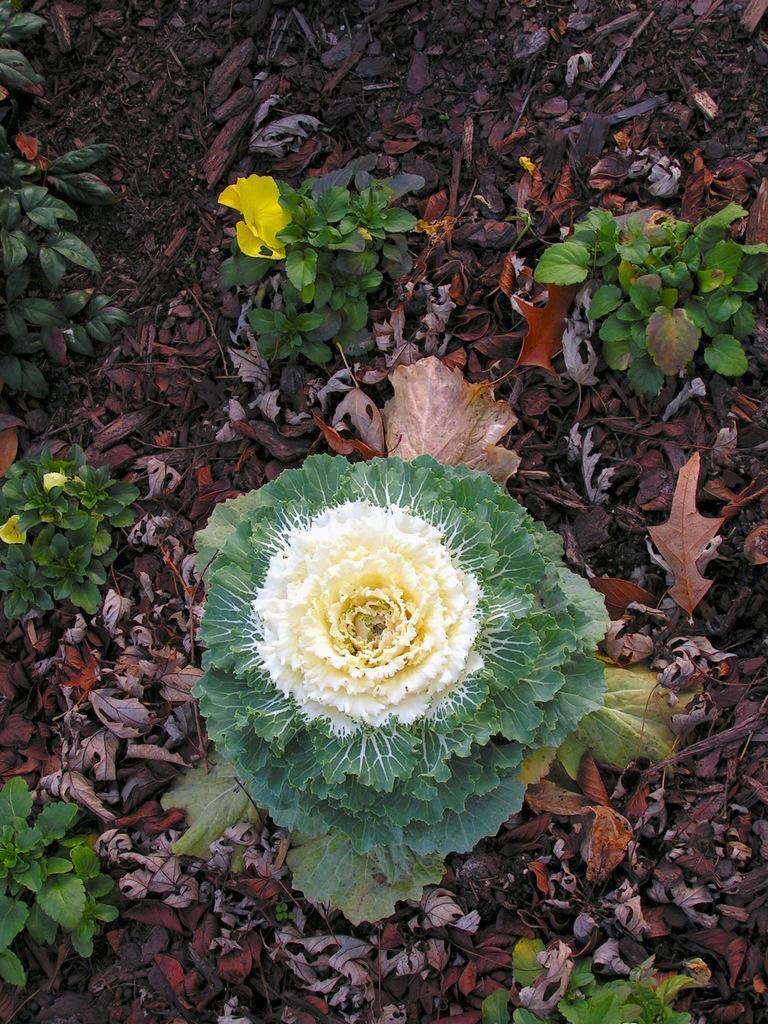Can you describe this image briefly? In the picture we can see a surface with dried leaves and some small plants with yellow color flower on it and one flower with thrones to it. 